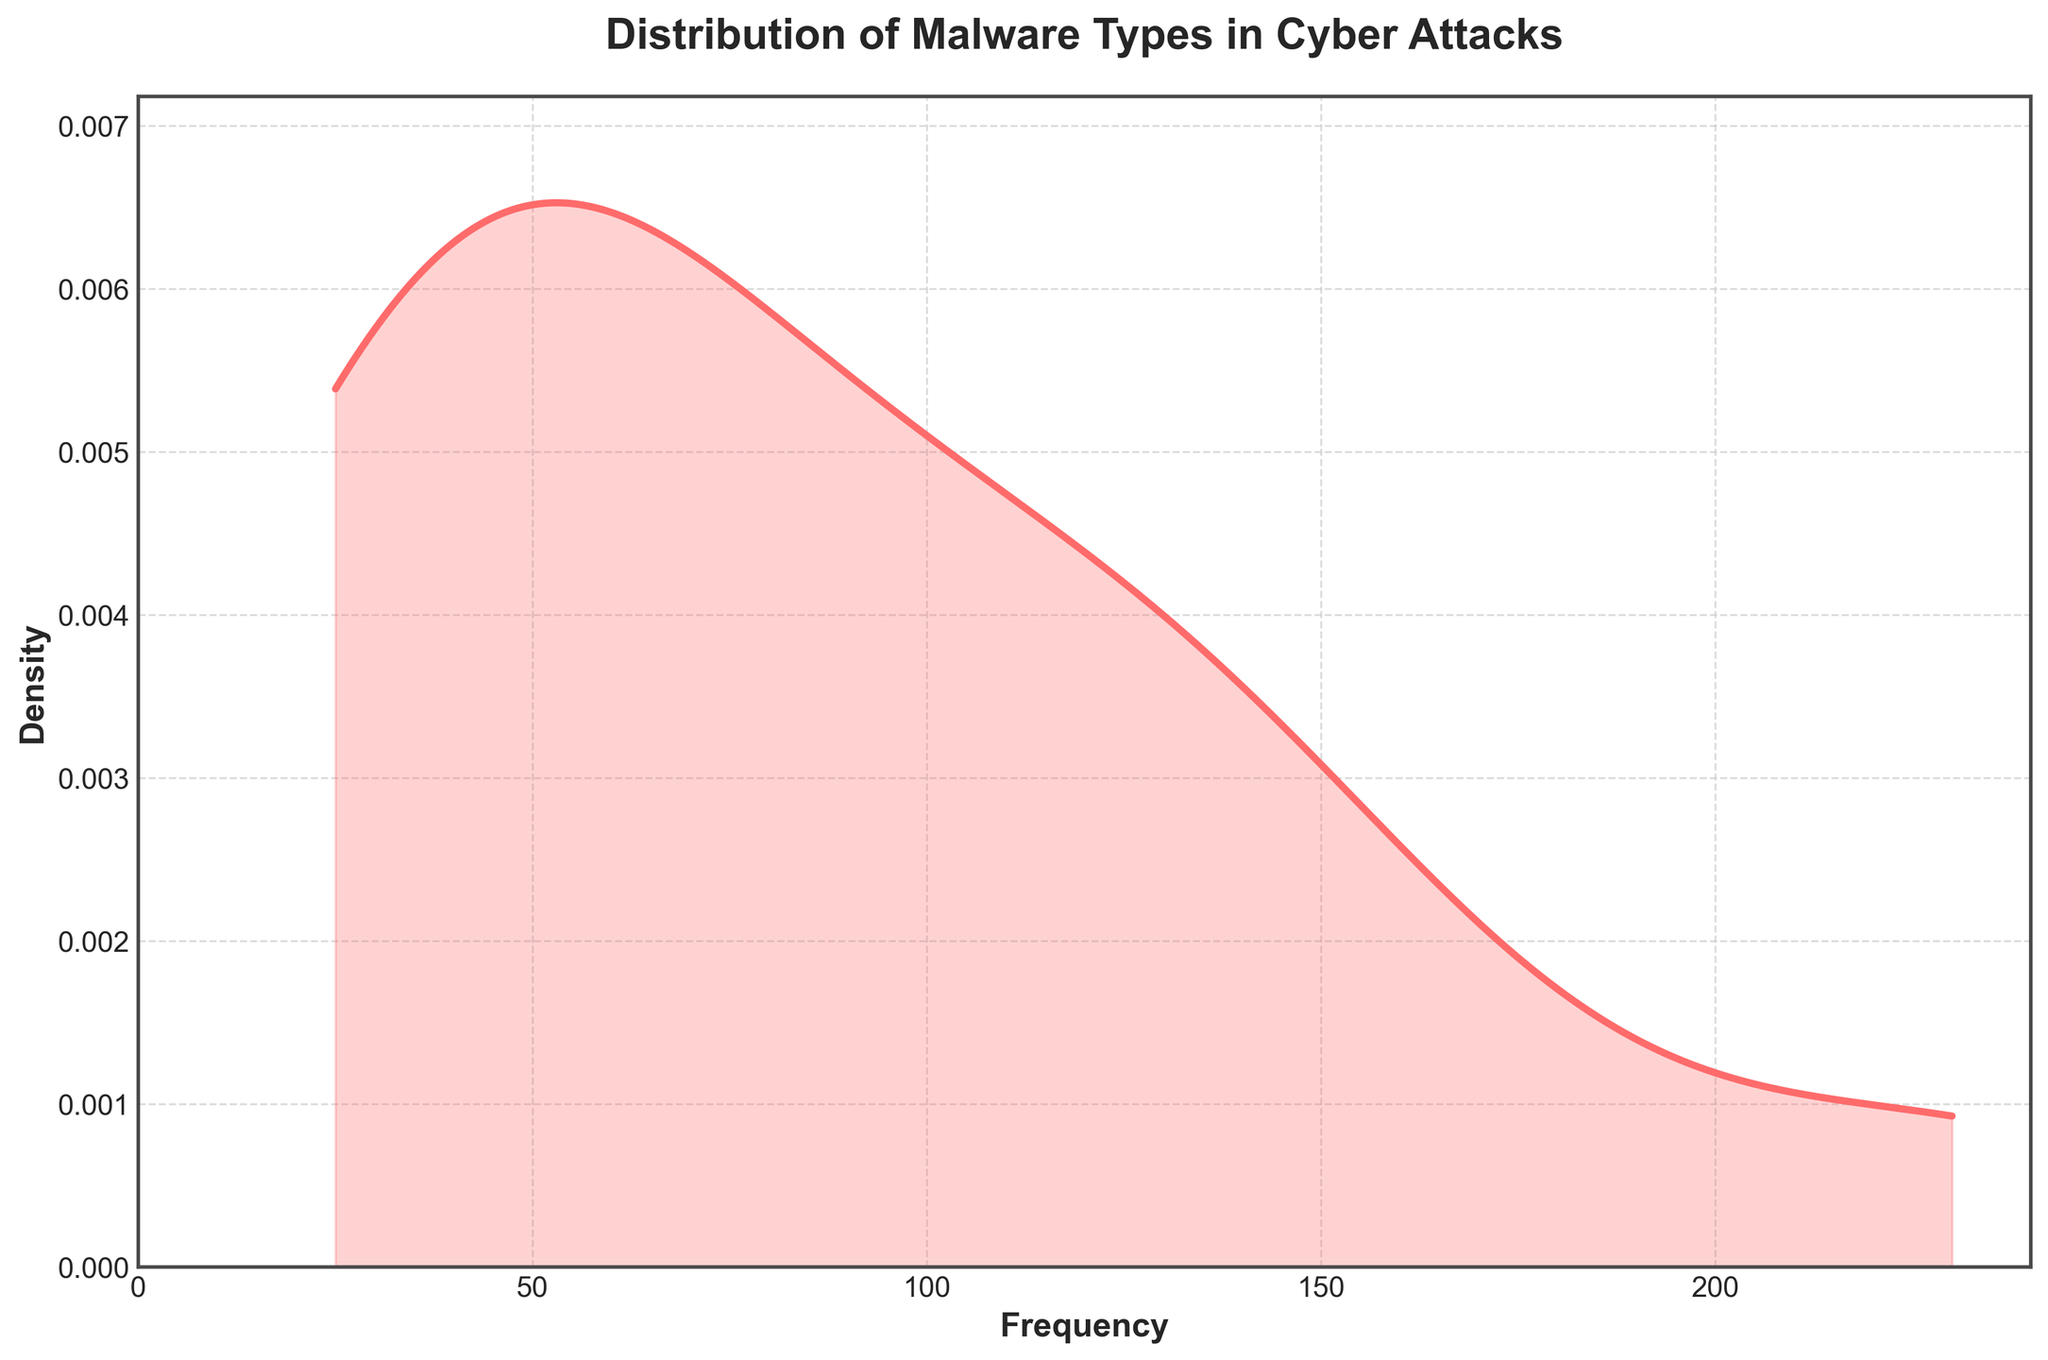What is the title of the plot? The title of the plot is displayed at the top of the figure, usually in a bold font. This title helps viewers understand the primary focus of the figure.
Answer: Distribution of Malware Types in Cyber Attacks What are the units used on the x-axis? The units on the x-axis represent the frequency of malware types observed in cyber attacks. This can be inferred from the context provided by the figure.
Answer: Frequency What color is used for the density plot line? The density plot line's color is visible and distinguished from the background, typically involving visual inspection of the plot.
Answer: Red (or close to #FF6B6B) Which malware type has the highest frequency based on the density plot? To determine the malware type with the highest frequency, identify the peak of the density plot, which corresponds to the most common malware type.
Answer: Trojans What is the approximate maximum value on the x-axis? The x-axis's maximum value is visible by looking at the extent of the axis, often with a buffer to ensure all data is clearly represented.
Answer: Approximately 240 How does the density of malware types with a frequency below 50 compare to those above 100? Assess the plot by examining areas under the density curve below 50 and those above 100, comparing their visual representations.
Answer: Lower density below 50 compared to above 100 What trend is noticeable from the density plot in terms of the spread or variance of malware frequencies? The plot's spread or variance can be observed through the width of the curve, indicating how concentrated or dispersed the frequencies are.
Answer: Malware types are more concentrated around certain frequencies, particularly around 100-150 What is the general shape of the density plot? Observing the plot's shape, which is determined by variations in frequency density, reveals the distribution style (e.g., unimodal, bimodal, skewed).
Answer: Unimodal with right skew How does the density plot help in understanding the distribution of malware types? Understanding the density plot's functionality involves recognizing its role in showing how frequencies of different malware types are distributed and concentrated.
Answer: Highlights concentration and spread of malware frequencies What is one advantage of using a density plot for this data compared to a histogram? Recognizing the density plot's benefits requires understanding its ability to provide a smooth estimate of the distribution, unlike the more segmented histogram approach.
Answer: Provides a smoother view of distribution 